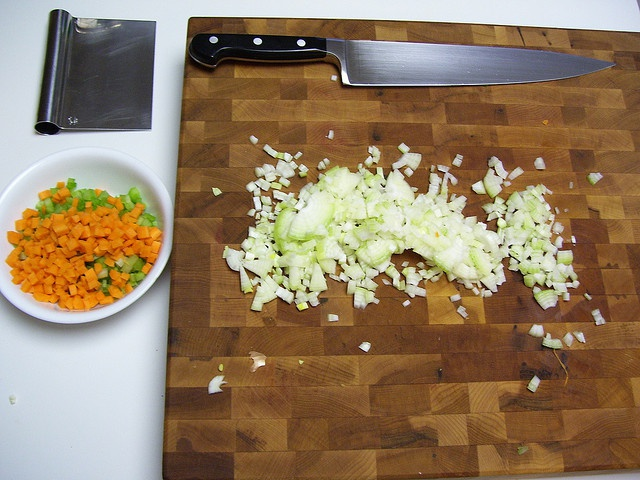Describe the objects in this image and their specific colors. I can see dining table in darkgray and lightgray tones, bowl in darkgray, lightgray, orange, and red tones, knife in darkgray, gray, and black tones, and carrot in darkgray, orange, red, and olive tones in this image. 